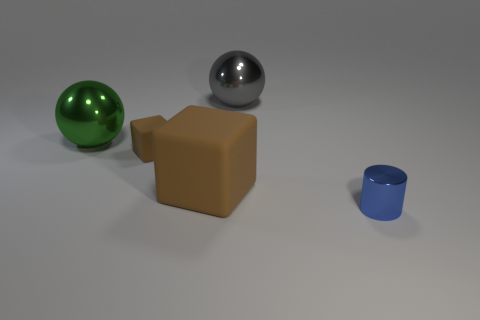Add 4 small brown rubber objects. How many objects exist? 9 Subtract all green spheres. How many spheres are left? 1 Subtract 1 spheres. How many spheres are left? 1 Subtract all blue cylinders. How many yellow spheres are left? 0 Add 5 brown matte things. How many brown matte things are left? 7 Add 1 large brown cubes. How many large brown cubes exist? 2 Subtract 0 gray cylinders. How many objects are left? 5 Subtract all cylinders. How many objects are left? 4 Subtract all yellow cylinders. Subtract all cyan balls. How many cylinders are left? 1 Subtract all big things. Subtract all small red metal cylinders. How many objects are left? 2 